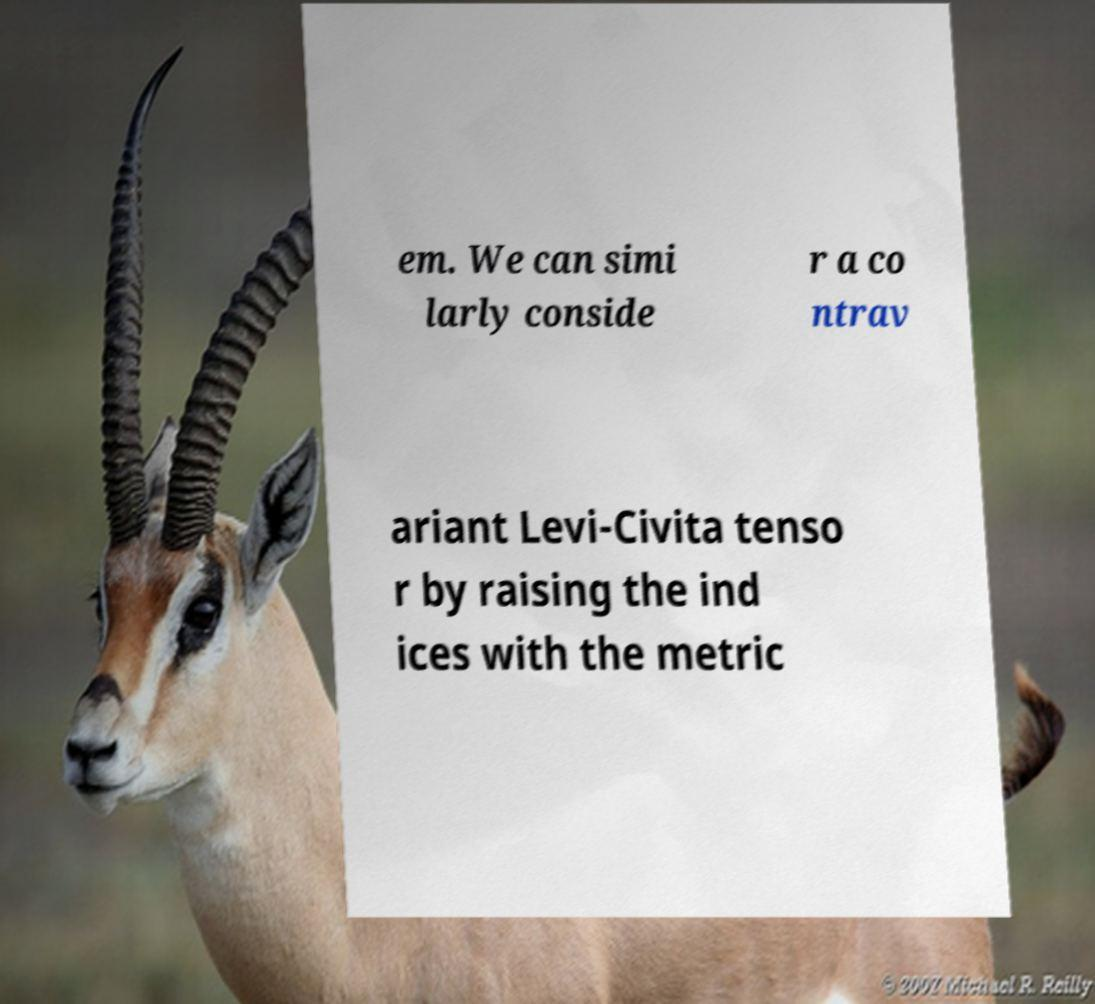For documentation purposes, I need the text within this image transcribed. Could you provide that? em. We can simi larly conside r a co ntrav ariant Levi-Civita tenso r by raising the ind ices with the metric 